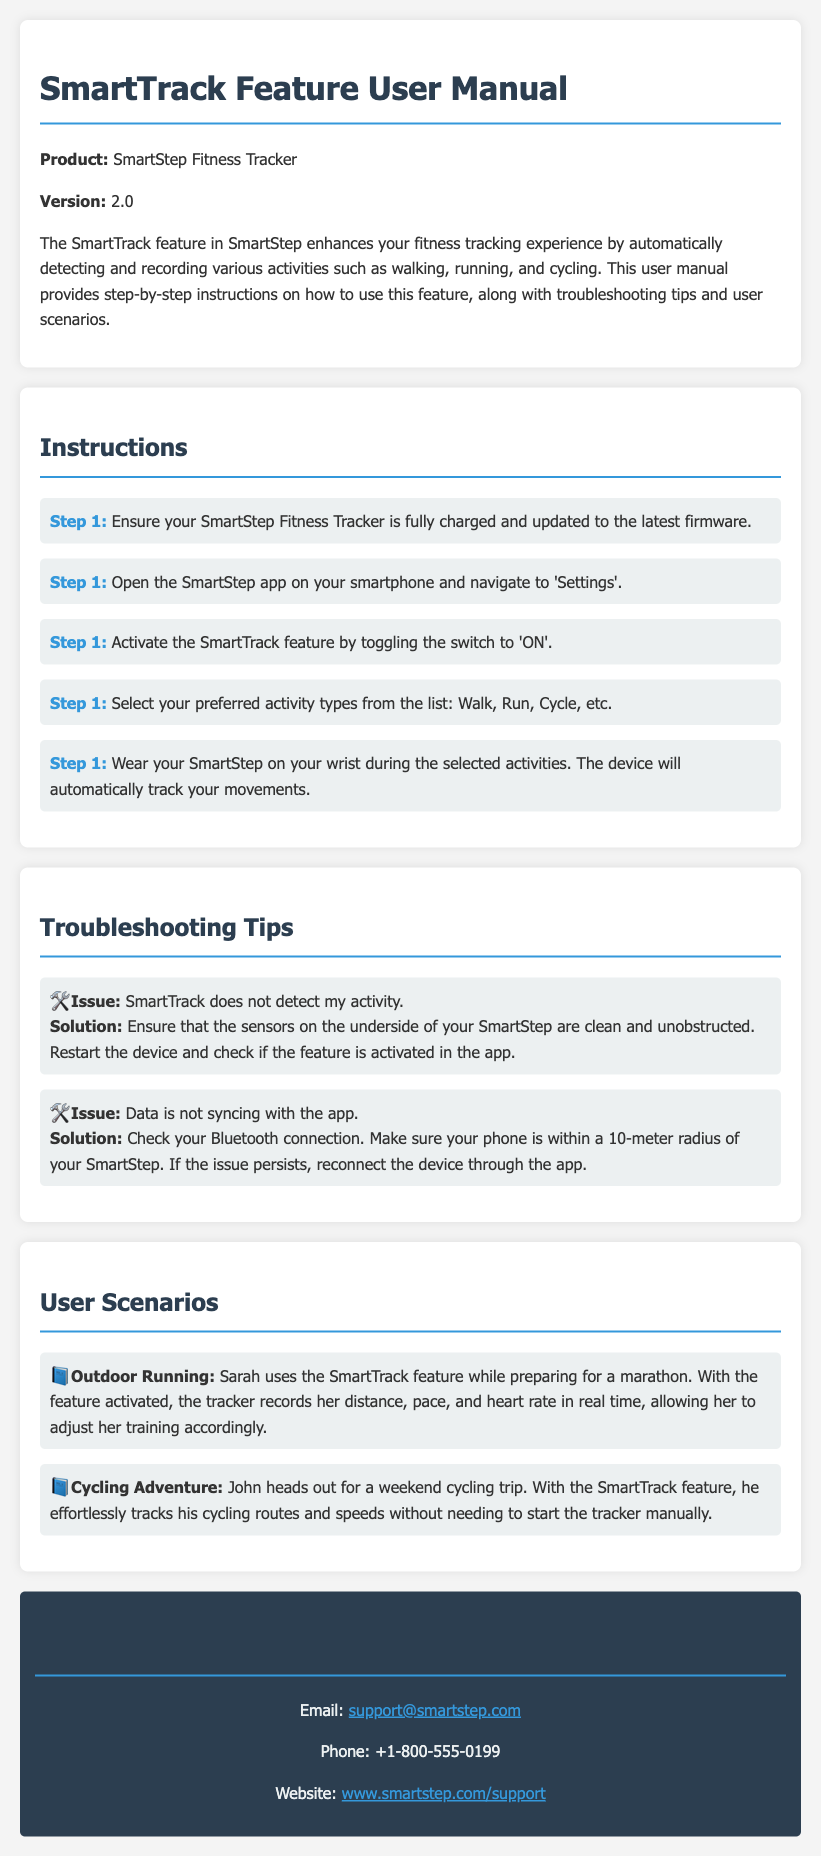What is the product name? The product name is mentioned in the document as "SmartStep Fitness Tracker."
Answer: SmartStep Fitness Tracker What version is the user manual for? The version number is specified in the document as "2.0."
Answer: 2.0 How many steps are provided in the instructions? The instructions section lists five steps for using the SmartTrack feature.
Answer: 5 What should you do if SmartTrack does not detect your activity? The document suggests ensuring that the sensors are clean and restarting the device.
Answer: Clean sensors and restart device What activity types can be selected? The document lists "Walk, Run, Cycle, etc." as the preferred activity types that can be selected.
Answer: Walk, Run, Cycle, etc What is a scenario example for outdoor running? The example given describes a user named Sarah preparing for a marathon.
Answer: Sarah preparing for a marathon How can you activate the SmartTrack feature? The document states to toggle the switch to 'ON' in the SmartStep app under 'Settings.'
Answer: Toggle the switch to 'ON' What is the contact email for support? The email address for support is provided in the contact information section.
Answer: support@smartstep.com What should you check if data is not syncing with the app? The document recommends checking the Bluetooth connection and making sure the phone is within the required distance.
Answer: Check Bluetooth connection 